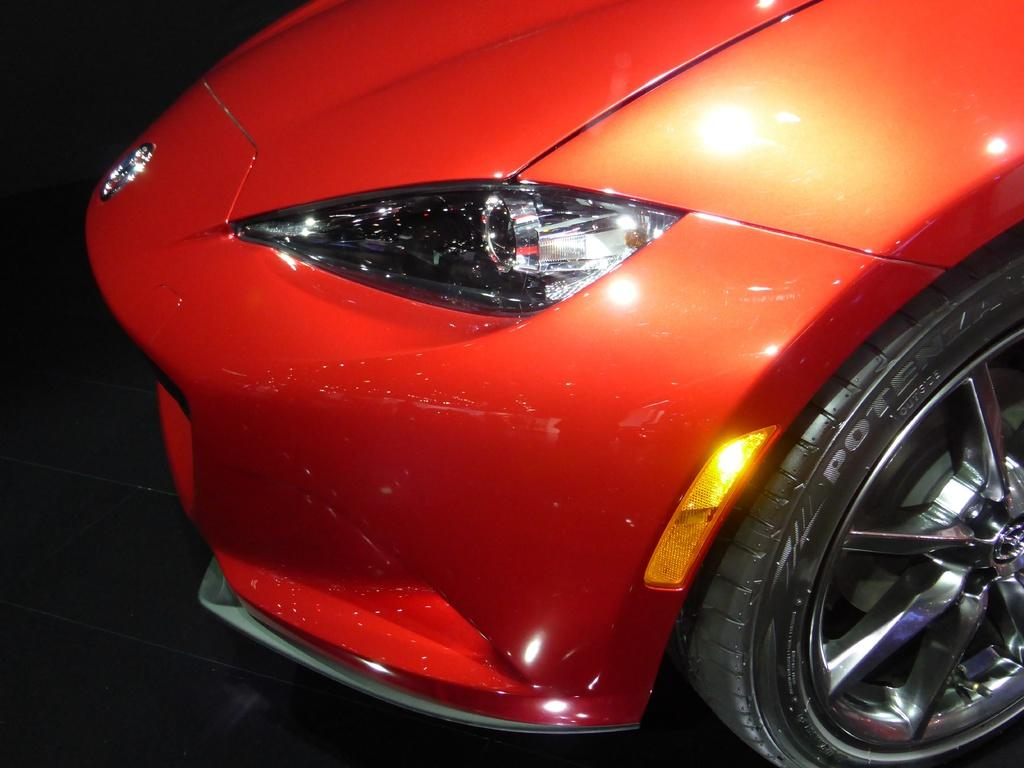What is the main subject of the picture? The main subject of the picture is a vehicle. Can you describe the color of the vehicle? The vehicle is red in color. Can you tell me how many rats are sitting on the vehicle in the image? There are no rats present in the image; it only features a red vehicle. What type of conversation is happening between the vehicle and the viewer in the image? There is no conversation happening between the vehicle and the viewer in the image, as vehicles cannot talk. 